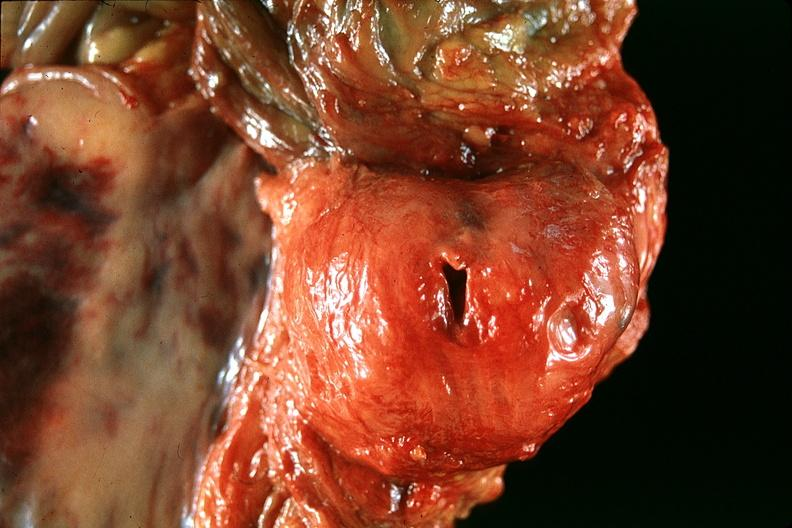where is this?
Answer the question using a single word or phrase. Urinary 